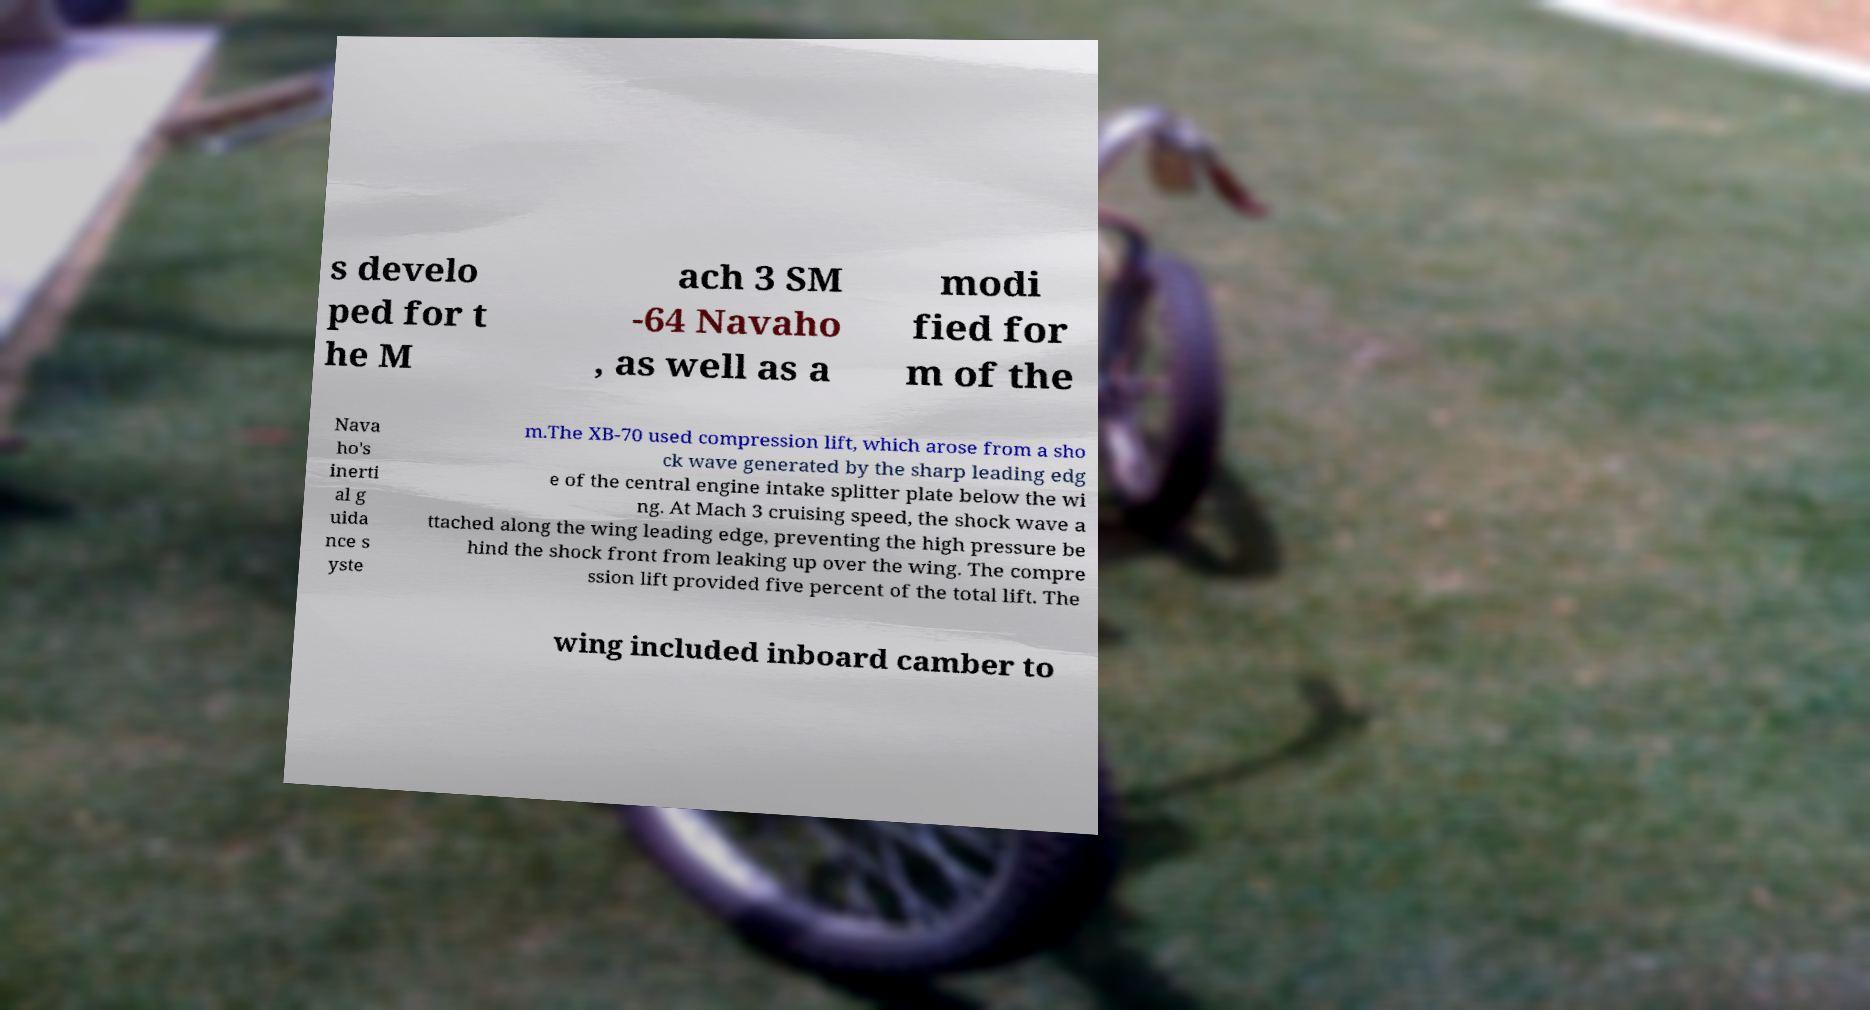Please identify and transcribe the text found in this image. s develo ped for t he M ach 3 SM -64 Navaho , as well as a modi fied for m of the Nava ho's inerti al g uida nce s yste m.The XB-70 used compression lift, which arose from a sho ck wave generated by the sharp leading edg e of the central engine intake splitter plate below the wi ng. At Mach 3 cruising speed, the shock wave a ttached along the wing leading edge, preventing the high pressure be hind the shock front from leaking up over the wing. The compre ssion lift provided five percent of the total lift. The wing included inboard camber to 